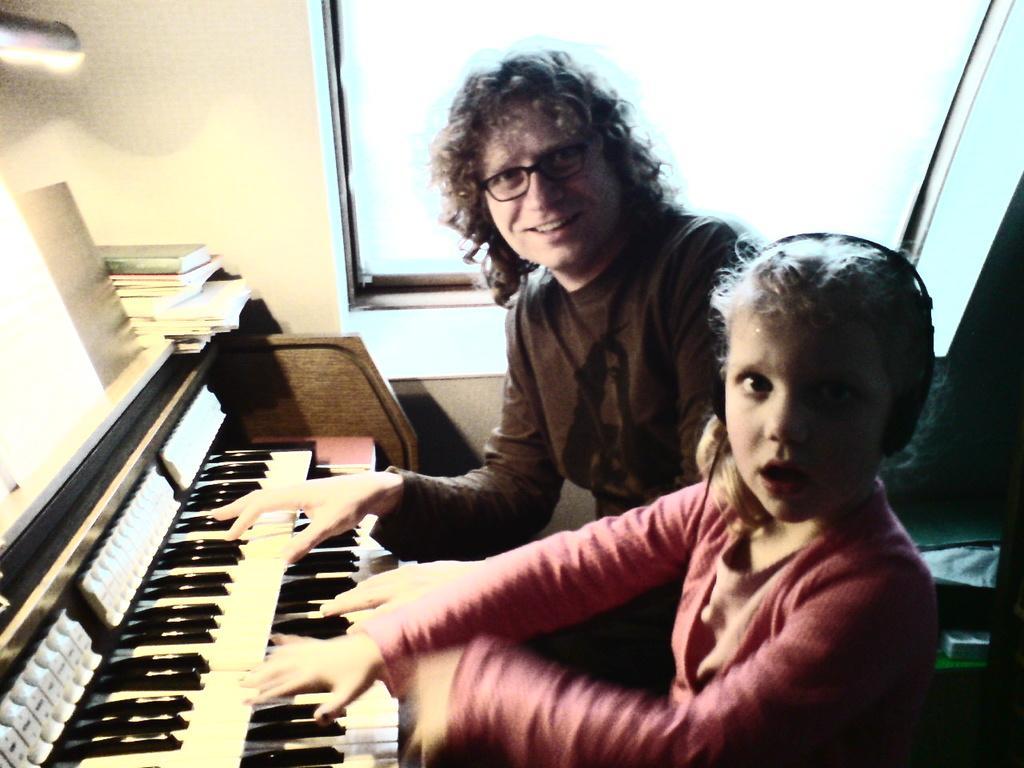How would you summarize this image in a sentence or two? In this image I can see two people are giving pose to the picture and both are playing the piano. In the background there is a window and a wall. Beside this piano there are few books. On the right side the girl is wearing pink color dress and head set. 